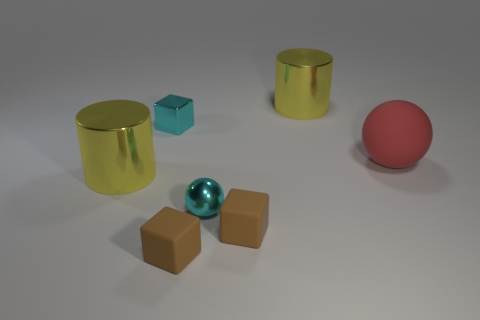What number of other things are the same size as the red rubber ball?
Offer a very short reply. 2. Is the number of small shiny things behind the red rubber object greater than the number of small purple shiny blocks?
Keep it short and to the point. Yes. Are there any other things that are the same color as the shiny ball?
Your answer should be compact. Yes. What shape is the tiny object that is the same material as the cyan sphere?
Offer a terse response. Cube. Do the small brown object to the right of the small shiny sphere and the big red sphere have the same material?
Your answer should be very brief. Yes. What is the shape of the small metal thing that is the same color as the tiny metal cube?
Keep it short and to the point. Sphere. Does the shiny cylinder that is behind the matte sphere have the same color as the big shiny thing to the left of the tiny cyan cube?
Give a very brief answer. Yes. What number of things are both on the right side of the metallic sphere and in front of the tiny cyan ball?
Your response must be concise. 1. What material is the large red ball?
Offer a terse response. Rubber. There is a cyan object that is the same size as the shiny sphere; what is its shape?
Provide a short and direct response. Cube. 